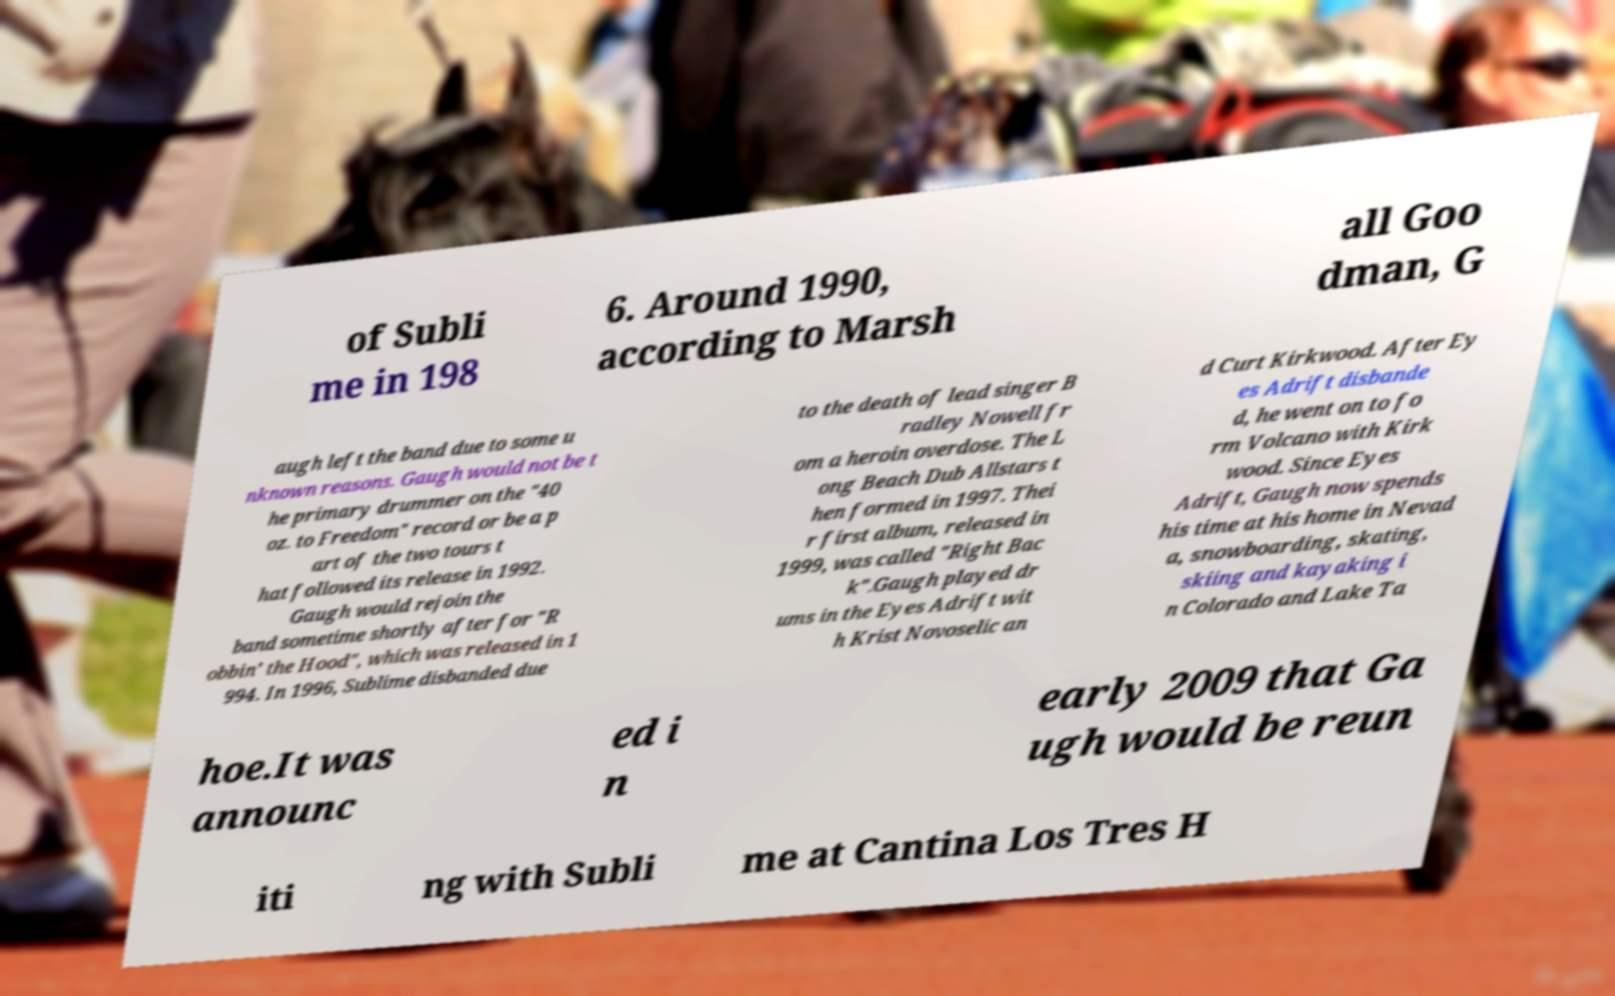There's text embedded in this image that I need extracted. Can you transcribe it verbatim? of Subli me in 198 6. Around 1990, according to Marsh all Goo dman, G augh left the band due to some u nknown reasons. Gaugh would not be t he primary drummer on the "40 oz. to Freedom" record or be a p art of the two tours t hat followed its release in 1992. Gaugh would rejoin the band sometime shortly after for "R obbin’ the Hood", which was released in 1 994. In 1996, Sublime disbanded due to the death of lead singer B radley Nowell fr om a heroin overdose. The L ong Beach Dub Allstars t hen formed in 1997. Thei r first album, released in 1999, was called "Right Bac k".Gaugh played dr ums in the Eyes Adrift wit h Krist Novoselic an d Curt Kirkwood. After Ey es Adrift disbande d, he went on to fo rm Volcano with Kirk wood. Since Eyes Adrift, Gaugh now spends his time at his home in Nevad a, snowboarding, skating, skiing and kayaking i n Colorado and Lake Ta hoe.It was announc ed i n early 2009 that Ga ugh would be reun iti ng with Subli me at Cantina Los Tres H 